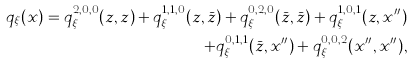Convert formula to latex. <formula><loc_0><loc_0><loc_500><loc_500>q _ { \xi } ( x ) = q ^ { 2 , 0 , 0 } _ { \xi } ( z , z ) + q ^ { 1 , 1 , 0 } _ { \xi } ( z , \bar { z } ) + q ^ { 0 , 2 , 0 } _ { \xi } ( \bar { z } , \bar { z } ) + q ^ { 1 , 0 , 1 } _ { \xi } ( { z } , x ^ { \prime \prime } ) \\ + q ^ { 0 , 1 , 1 } _ { \xi } ( \bar { z } , x ^ { \prime \prime } ) + q ^ { 0 , 0 , 2 } _ { \xi } ( x ^ { \prime \prime } , x ^ { \prime \prime } ) ,</formula> 